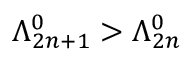Convert formula to latex. <formula><loc_0><loc_0><loc_500><loc_500>\Lambda _ { 2 n + 1 } ^ { 0 } > \Lambda _ { 2 n } ^ { 0 }</formula> 